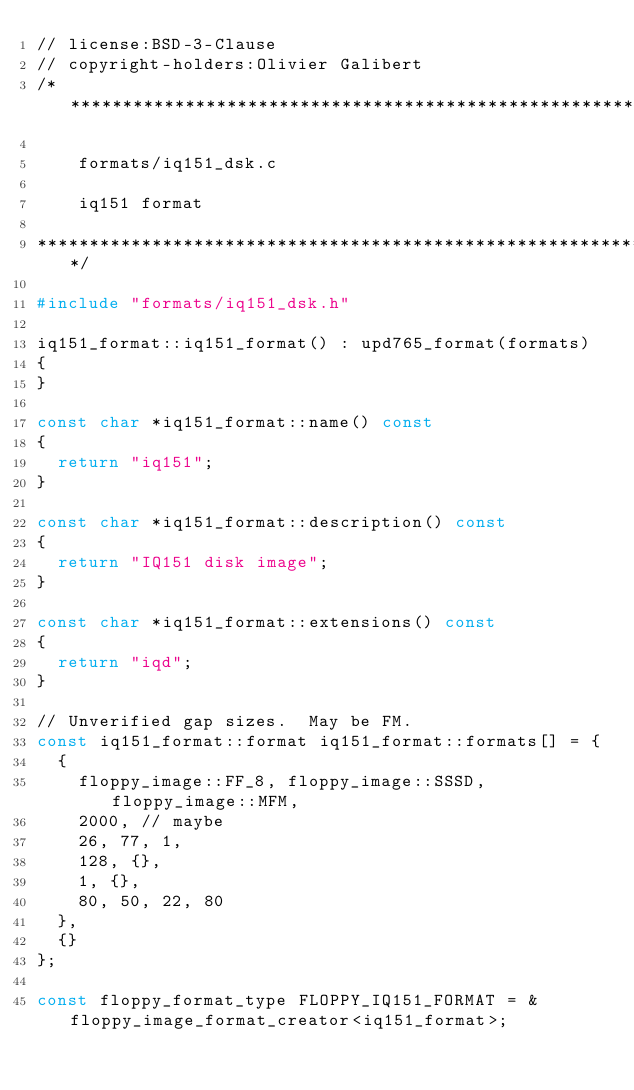<code> <loc_0><loc_0><loc_500><loc_500><_C++_>// license:BSD-3-Clause
// copyright-holders:Olivier Galibert
/*********************************************************************

    formats/iq151_dsk.c

    iq151 format

*********************************************************************/

#include "formats/iq151_dsk.h"

iq151_format::iq151_format() : upd765_format(formats)
{
}

const char *iq151_format::name() const
{
	return "iq151";
}

const char *iq151_format::description() const
{
	return "IQ151 disk image";
}

const char *iq151_format::extensions() const
{
	return "iqd";
}

// Unverified gap sizes.  May be FM.
const iq151_format::format iq151_format::formats[] = {
	{
		floppy_image::FF_8, floppy_image::SSSD, floppy_image::MFM,
		2000, // maybe
		26, 77, 1,
		128, {},
		1, {},
		80, 50, 22, 80
	},
	{}
};

const floppy_format_type FLOPPY_IQ151_FORMAT = &floppy_image_format_creator<iq151_format>;
</code> 